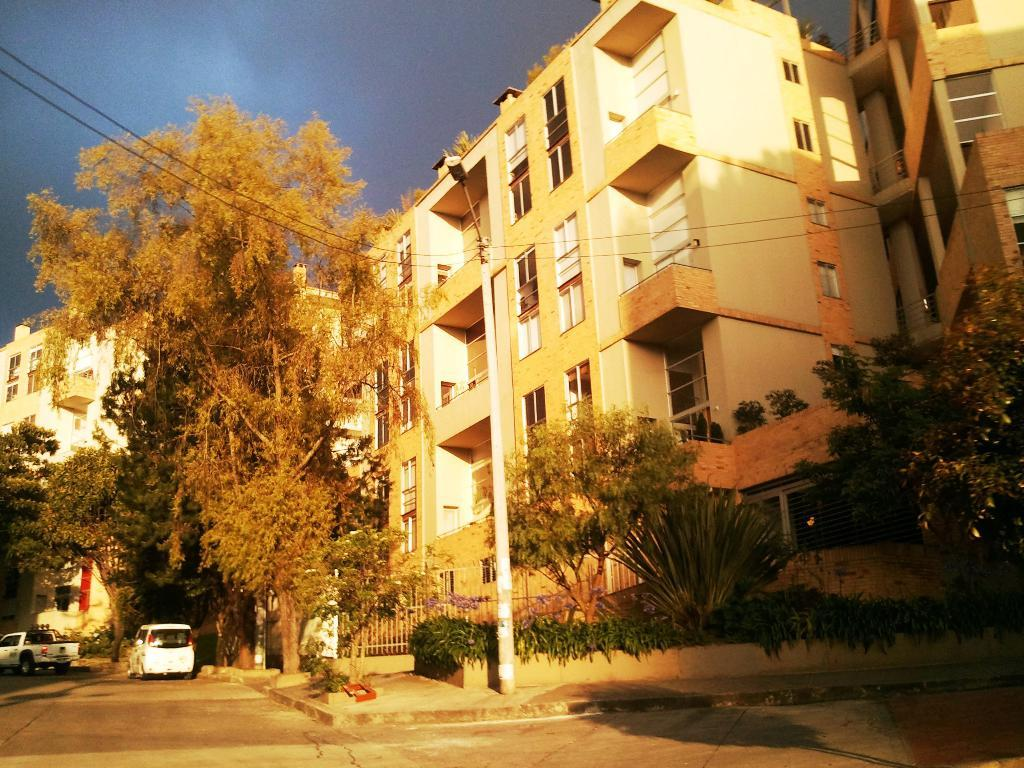What is the main feature of the image? There is a road in the image. What else can be seen on the road? There are vehicles in the image. What is attached to the pole in the image? There is a light and wires on the pole in the image. What type of vegetation is present in the image? There are trees in the image. What type of structures are visible in the image? There are buildings in the image. What is visible above the structures and trees? The sky is visible in the image. What type of education is being offered at the club in the image? There is no club or educational institution present in the image. What type of land can be seen in the image? The image does not specifically show a type of land; it features a road, vehicles, a pole with a light and wires, trees, buildings, and the sky. 